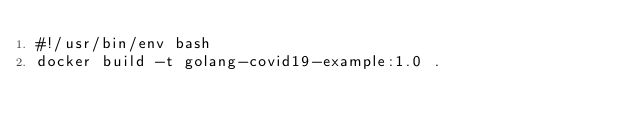<code> <loc_0><loc_0><loc_500><loc_500><_Bash_>#!/usr/bin/env bash
docker build -t golang-covid19-example:1.0 .
</code> 